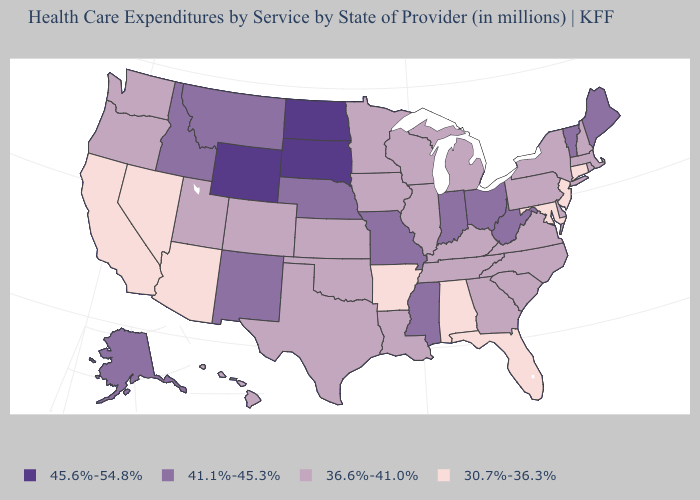Among the states that border Texas , does Arkansas have the lowest value?
Give a very brief answer. Yes. What is the highest value in the USA?
Keep it brief. 45.6%-54.8%. What is the value of West Virginia?
Quick response, please. 41.1%-45.3%. What is the value of New York?
Concise answer only. 36.6%-41.0%. Name the states that have a value in the range 45.6%-54.8%?
Give a very brief answer. North Dakota, South Dakota, Wyoming. Does South Carolina have the lowest value in the USA?
Short answer required. No. Name the states that have a value in the range 41.1%-45.3%?
Give a very brief answer. Alaska, Idaho, Indiana, Maine, Mississippi, Missouri, Montana, Nebraska, New Mexico, Ohio, Vermont, West Virginia. Among the states that border New Jersey , which have the highest value?
Concise answer only. Delaware, New York, Pennsylvania. Which states have the lowest value in the West?
Write a very short answer. Arizona, California, Nevada. Name the states that have a value in the range 30.7%-36.3%?
Keep it brief. Alabama, Arizona, Arkansas, California, Connecticut, Florida, Maryland, Nevada, New Jersey. What is the value of Tennessee?
Give a very brief answer. 36.6%-41.0%. Which states hav the highest value in the Northeast?
Be succinct. Maine, Vermont. What is the lowest value in the USA?
Answer briefly. 30.7%-36.3%. What is the value of Florida?
Concise answer only. 30.7%-36.3%. What is the value of Rhode Island?
Short answer required. 36.6%-41.0%. 